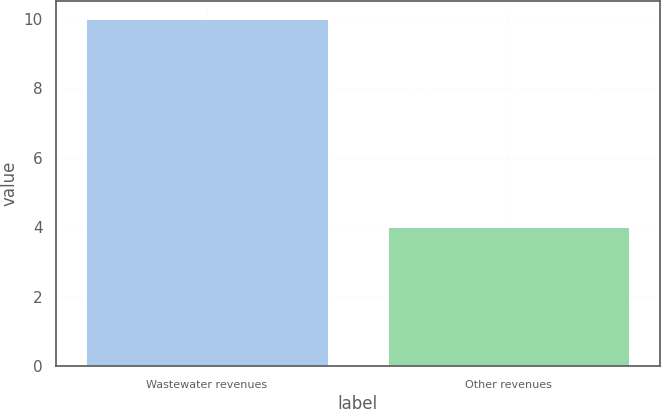Convert chart. <chart><loc_0><loc_0><loc_500><loc_500><bar_chart><fcel>Wastewater revenues<fcel>Other revenues<nl><fcel>10<fcel>4<nl></chart> 